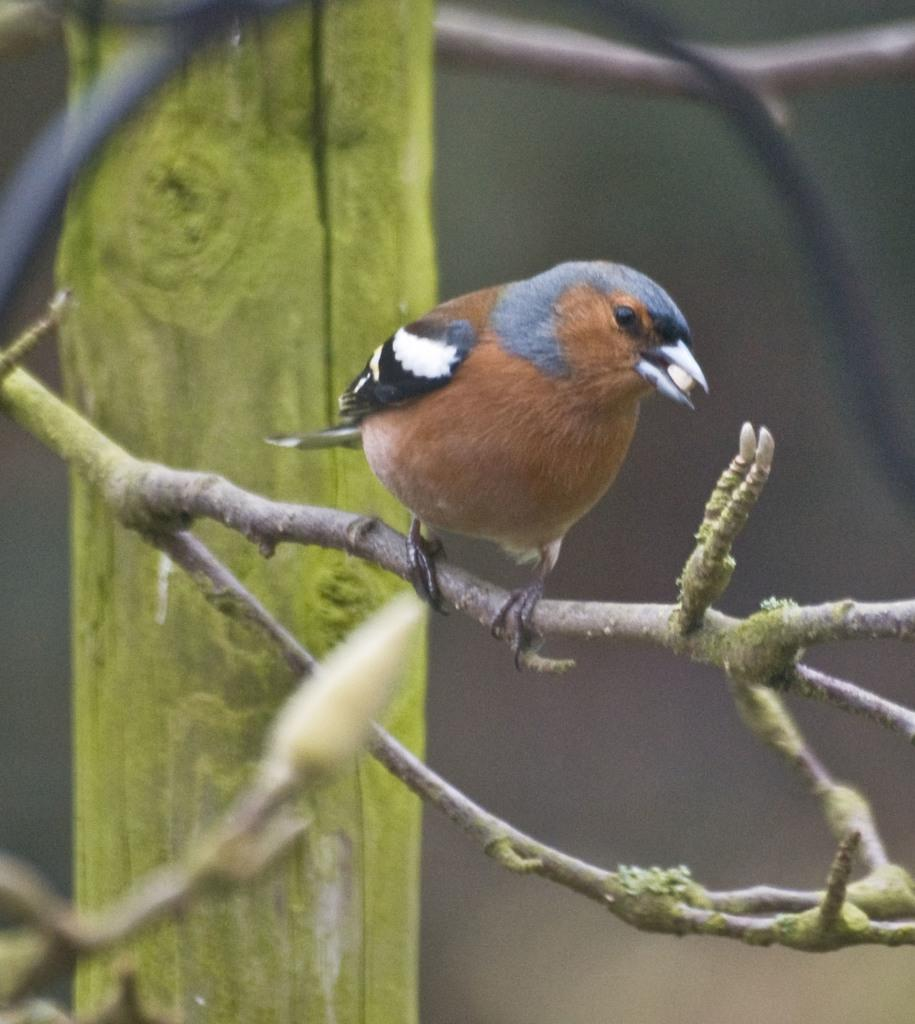What type of animal can be seen in the image? There is a brown bird in the image. Where is the bird located in the image? The bird is sitting on a stem. What else can be seen in the background of the image? There is a stick in the background of the image. Can you tell me how many friends the bird has in the image? There is no indication of friends in the image; it only features a brown bird sitting on a stem. What type of tool is the bird using to fix the stem in the image? There is no tool, such as a wrench, present in the image. 